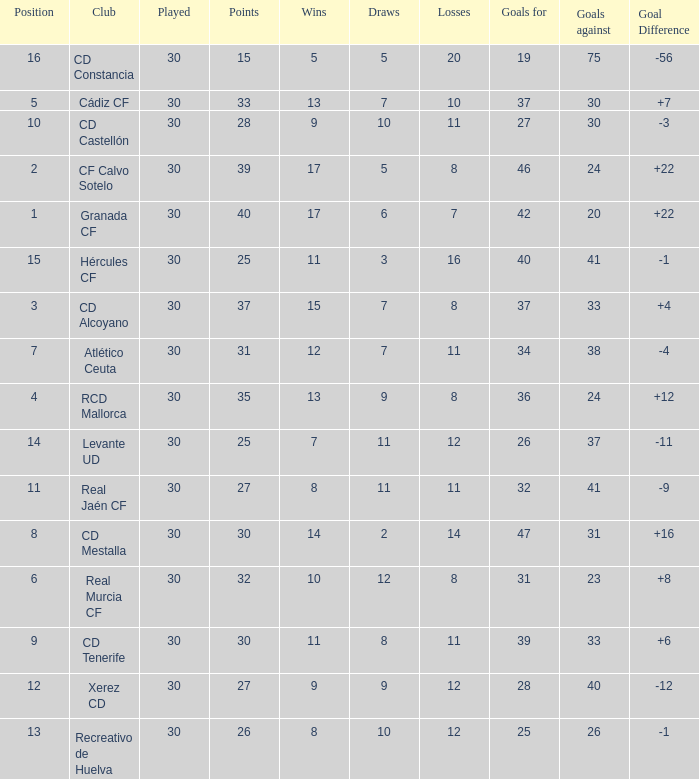Which Played has a Club of atlético ceuta, and less than 11 Losses? None. 